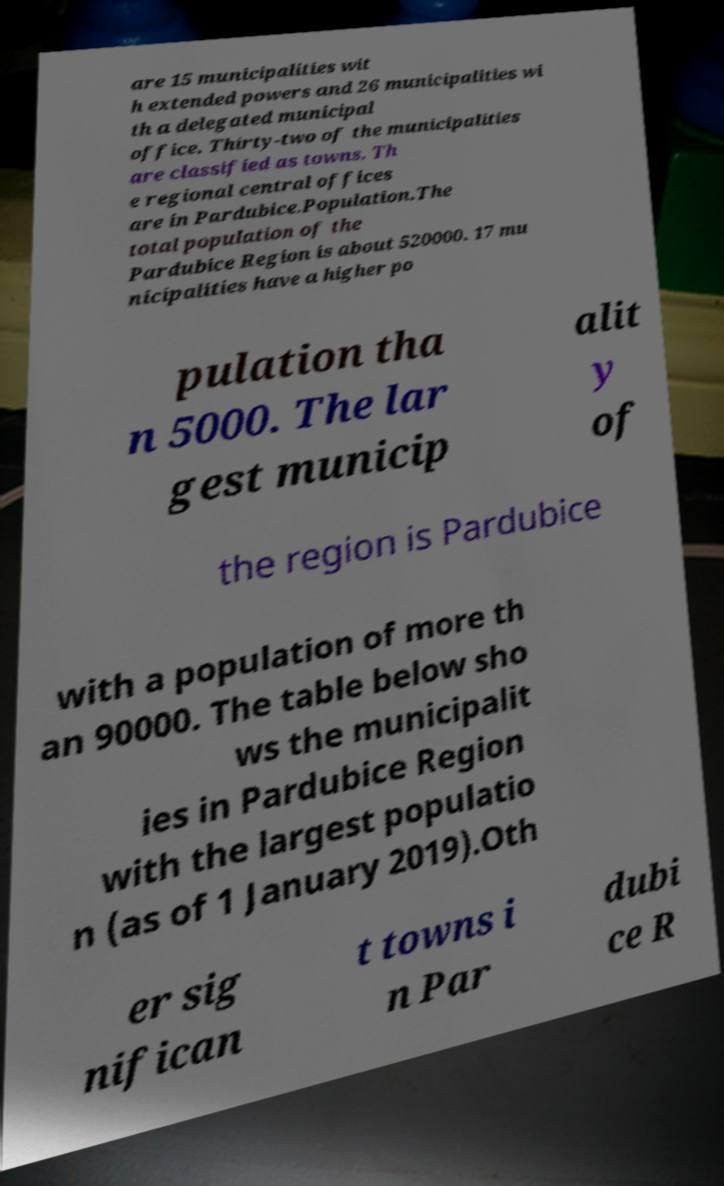For documentation purposes, I need the text within this image transcribed. Could you provide that? are 15 municipalities wit h extended powers and 26 municipalities wi th a delegated municipal office. Thirty-two of the municipalities are classified as towns. Th e regional central offices are in Pardubice.Population.The total population of the Pardubice Region is about 520000. 17 mu nicipalities have a higher po pulation tha n 5000. The lar gest municip alit y of the region is Pardubice with a population of more th an 90000. The table below sho ws the municipalit ies in Pardubice Region with the largest populatio n (as of 1 January 2019).Oth er sig nifican t towns i n Par dubi ce R 